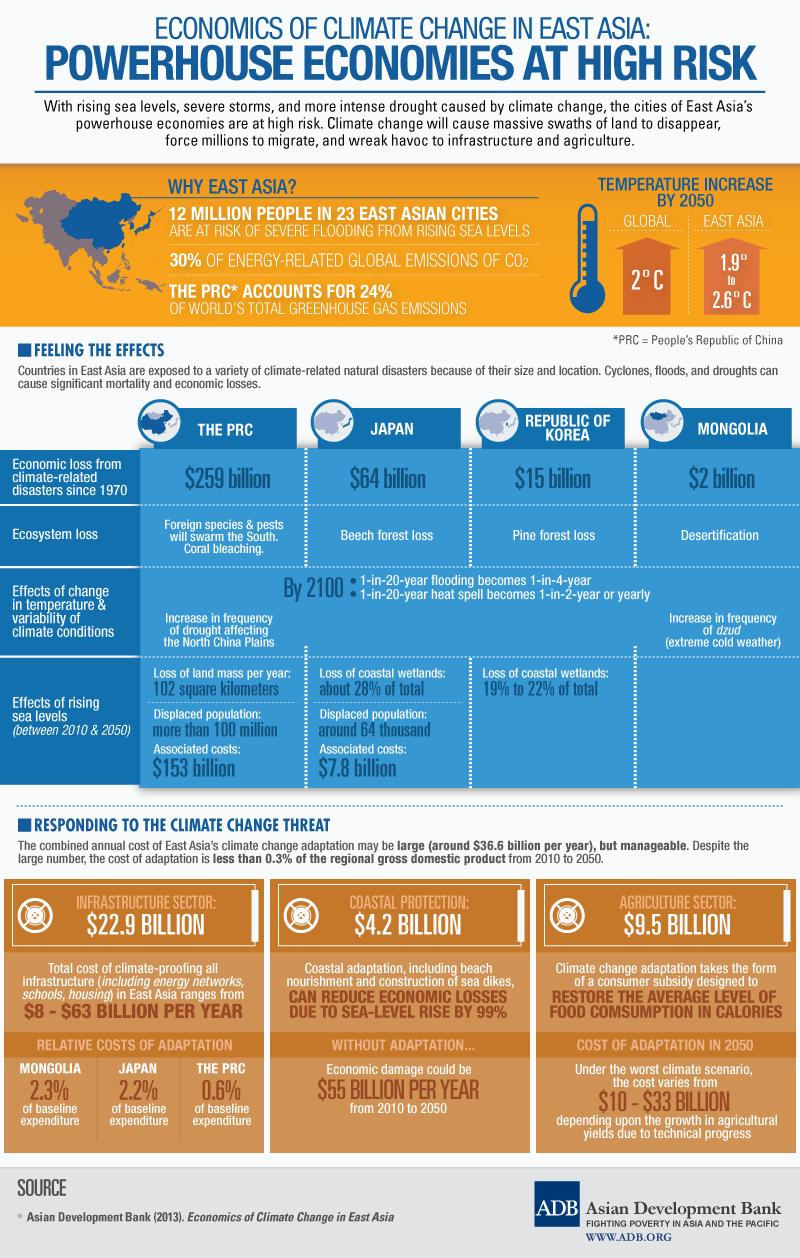Indicate a few pertinent items in this graphic. The cost of protecting the coastal regions of East Asia from the impacts of climate change is estimated to be $4.2 billion. According to recent estimates, approximately 64,000 people in Japan have been relocated due to rising sea level issues. According to estimates, the Republic of Korea has lost up to 19% to 22% of its total wetlands due to the rise in sea level. According to projections, the expected high temperature rise in East Asia by 2050 is expected to be approximately 2.6 degrees Celsius. In Japan, the rising sea level is estimated to have cost 7.8 billion due to its impact on the country's infrastructure and economy. 